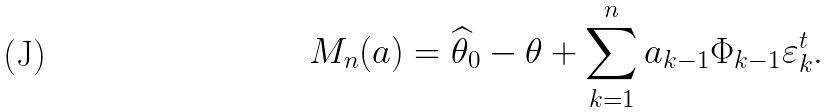<formula> <loc_0><loc_0><loc_500><loc_500>M _ { n } ( a ) = \widehat { \theta } _ { 0 } - \theta + \sum _ { k = 1 } ^ { n } a _ { k - 1 } \Phi _ { k - 1 } \varepsilon _ { k } ^ { t } .</formula> 